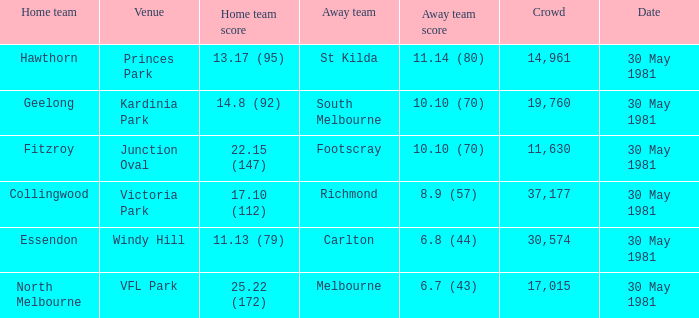What team played away at vfl park? Melbourne. 